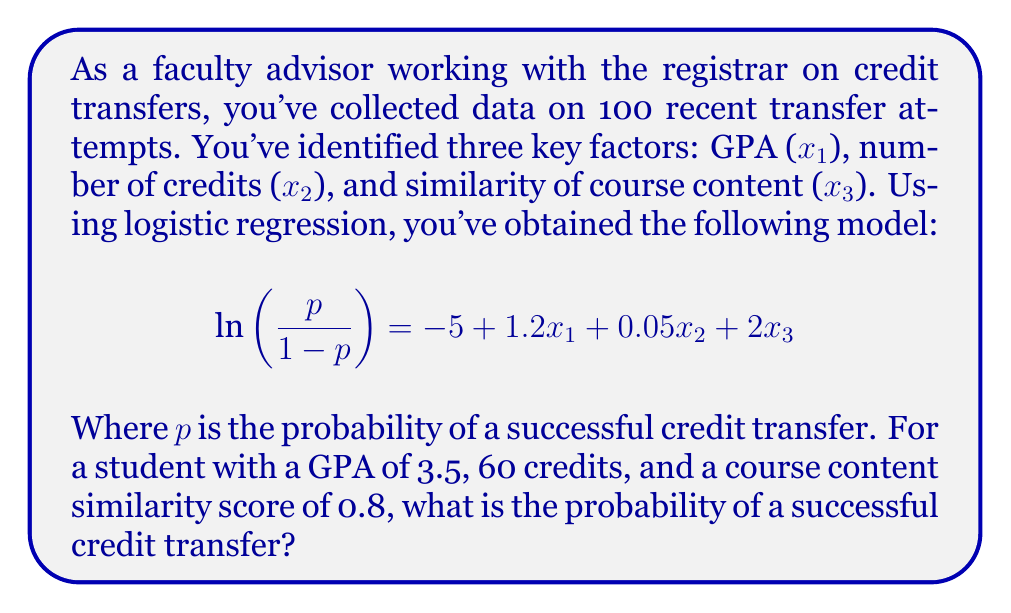Give your solution to this math problem. To solve this problem, we'll follow these steps:

1) First, let's substitute the given values into our logistic regression equation:
   $$\ln\left(\frac{p}{1-p}\right) = -5 + 1.2(3.5) + 0.05(60) + 2(0.8)$$

2) Now, let's calculate the right-hand side:
   $$\ln\left(\frac{p}{1-p}\right) = -5 + 4.2 + 3 + 1.6 = 3.8$$

3) This gives us the equation:
   $$\ln\left(\frac{p}{1-p}\right) = 3.8$$

4) To solve for p, we need to apply the exponential function to both sides:
   $$\frac{p}{1-p} = e^{3.8}$$

5) Calculate $e^{3.8}$:
   $$\frac{p}{1-p} \approx 44.7$$

6) Now we have:
   $$p = 44.7(1-p)$$
   $$p = 44.7 - 44.7p$$
   $$45.7p = 44.7$$

7) Solving for p:
   $$p = \frac{44.7}{45.7} \approx 0.9781$$

8) Convert to a percentage:
   $$0.9781 * 100\% = 97.81\%$$

Therefore, the probability of a successful credit transfer for this student is approximately 97.81%.
Answer: 97.81% 